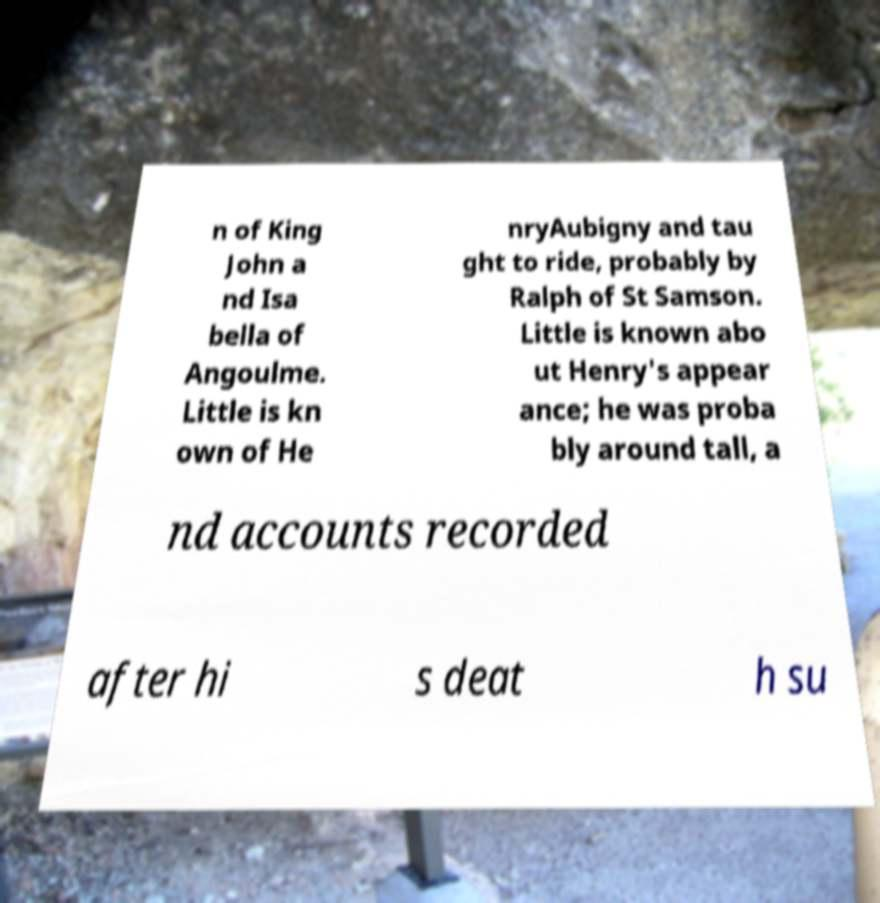Could you extract and type out the text from this image? n of King John a nd Isa bella of Angoulme. Little is kn own of He nryAubigny and tau ght to ride, probably by Ralph of St Samson. Little is known abo ut Henry's appear ance; he was proba bly around tall, a nd accounts recorded after hi s deat h su 